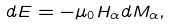<formula> <loc_0><loc_0><loc_500><loc_500>d E = - \mu _ { 0 } H _ { \alpha } d M _ { \alpha } ,</formula> 